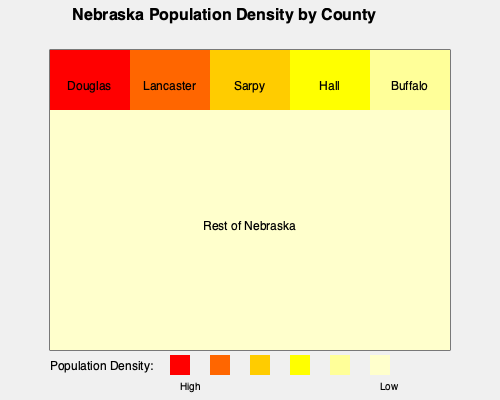Based on the heat map of Nebraska's population density by county, which statement best describes the population distribution in the state? To answer this question, we need to analyze the heat map provided:

1. The map shows six distinct areas, with five smaller areas at the top and one large area covering the rest of the state.

2. The color coding indicates population density, with darker colors (red, orange) representing higher density and lighter colors (yellow, pale yellow) representing lower density.

3. Looking at the labeled counties:
   - Douglas County (far left) has the darkest red, indicating the highest population density.
   - Lancaster County (second from left) has the second darkest color (orange), suggesting the second-highest density.
   - Sarpy County (middle) has a yellow-orange color, indicating moderate to high density.
   - Hall and Buffalo counties have lighter yellow colors, suggesting lower population densities.

4. The large area representing the rest of Nebraska has the lightest color, indicating very low population density across most of the state.

5. We can conclude that population is concentrated in a few urban counties, primarily in the eastern part of the state (Douglas, Lancaster, and Sarpy), with much lower density throughout the rest of Nebraska.

Given this analysis, the statement that best describes Nebraska's population distribution is that it is highly concentrated in a few urban counties, with sparse population across the majority of the state.
Answer: Highly concentrated in a few urban counties, sparse across most of the state. 